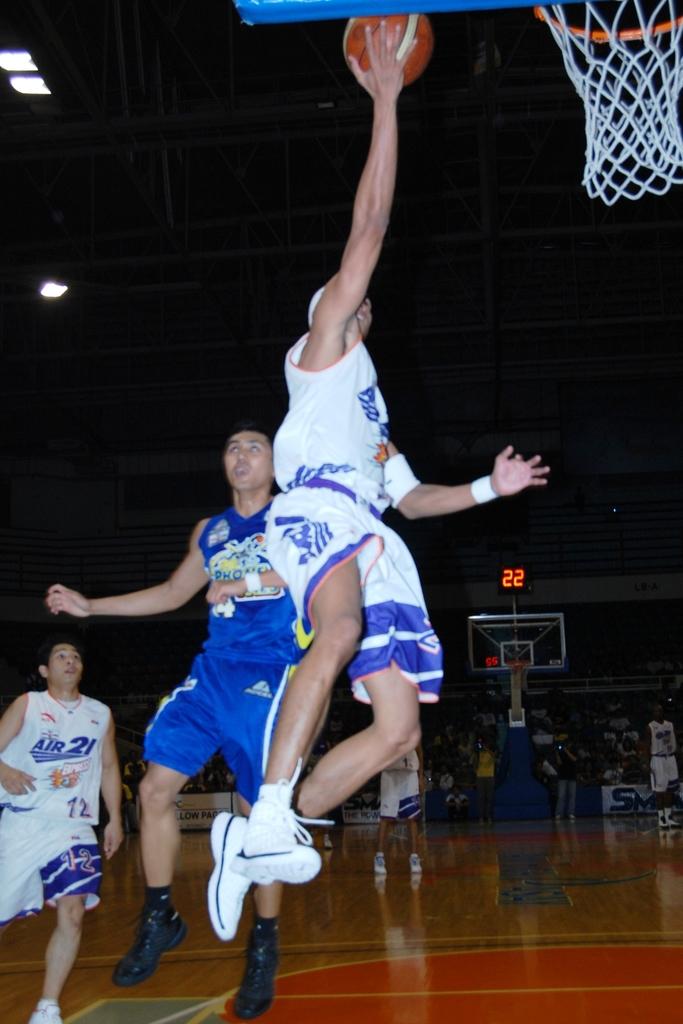What does it say on the player's jersey on the left?
Your answer should be very brief. Air 21. 